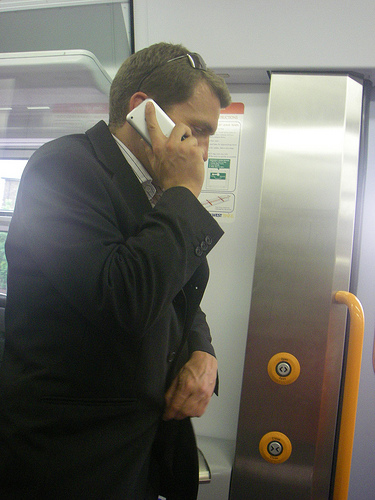Can you describe the overall setting of the image? The image shows a man inside a train or subway carriage. He is speaking on his phone while standing beside the train door, under a metallic panel that has buttons and emergency controls. He appears to be engrossed in his conversation. 